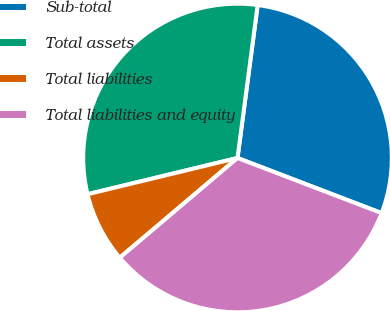<chart> <loc_0><loc_0><loc_500><loc_500><pie_chart><fcel>Sub-total<fcel>Total assets<fcel>Total liabilities<fcel>Total liabilities and equity<nl><fcel>28.73%<fcel>30.86%<fcel>7.41%<fcel>33.0%<nl></chart> 